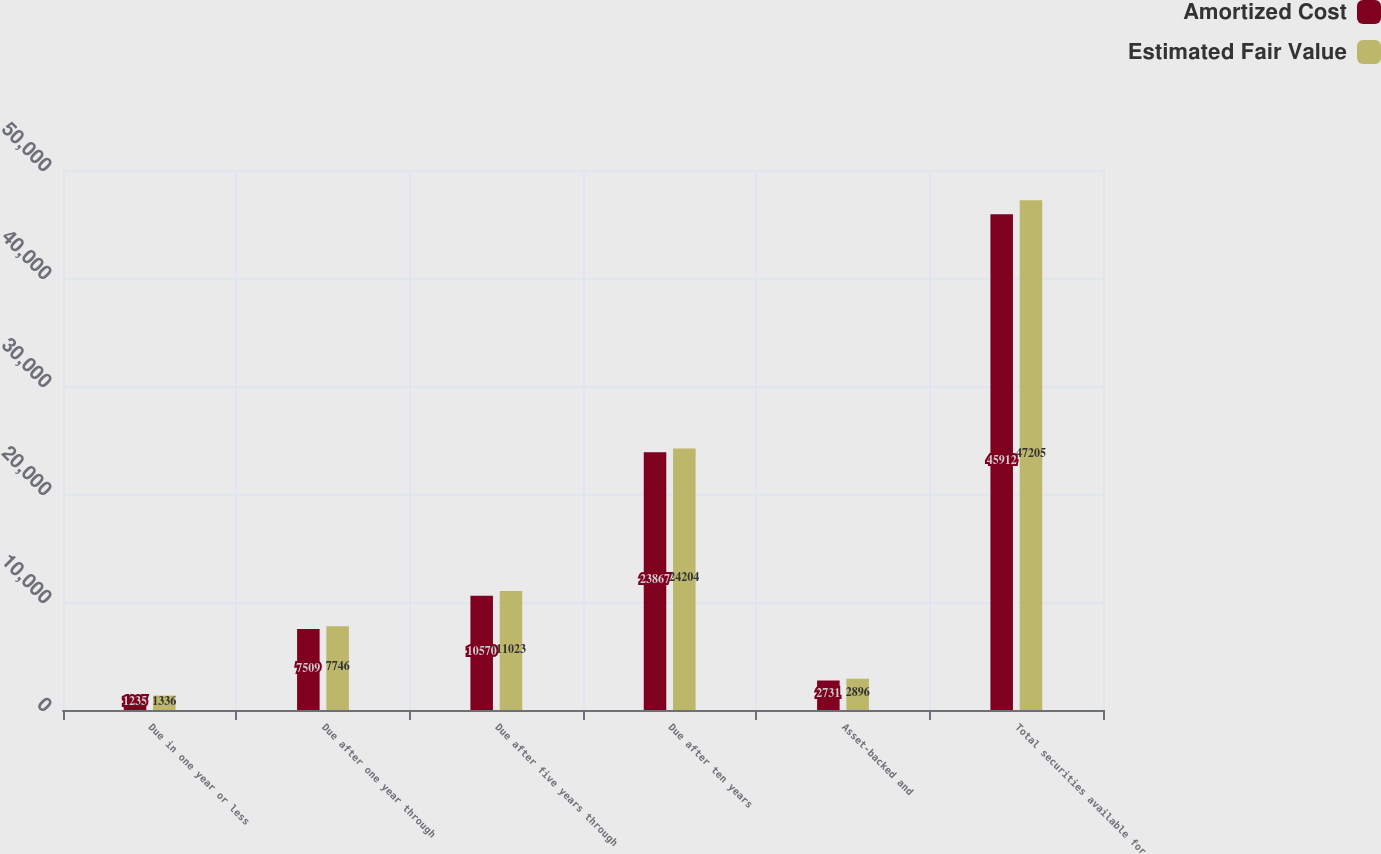<chart> <loc_0><loc_0><loc_500><loc_500><stacked_bar_chart><ecel><fcel>Due in one year or less<fcel>Due after one year through<fcel>Due after five years through<fcel>Due after ten years<fcel>Asset-backed and<fcel>Total securities available for<nl><fcel>Amortized Cost<fcel>1235<fcel>7509<fcel>10570<fcel>23867<fcel>2731<fcel>45912<nl><fcel>Estimated Fair Value<fcel>1336<fcel>7746<fcel>11023<fcel>24204<fcel>2896<fcel>47205<nl></chart> 